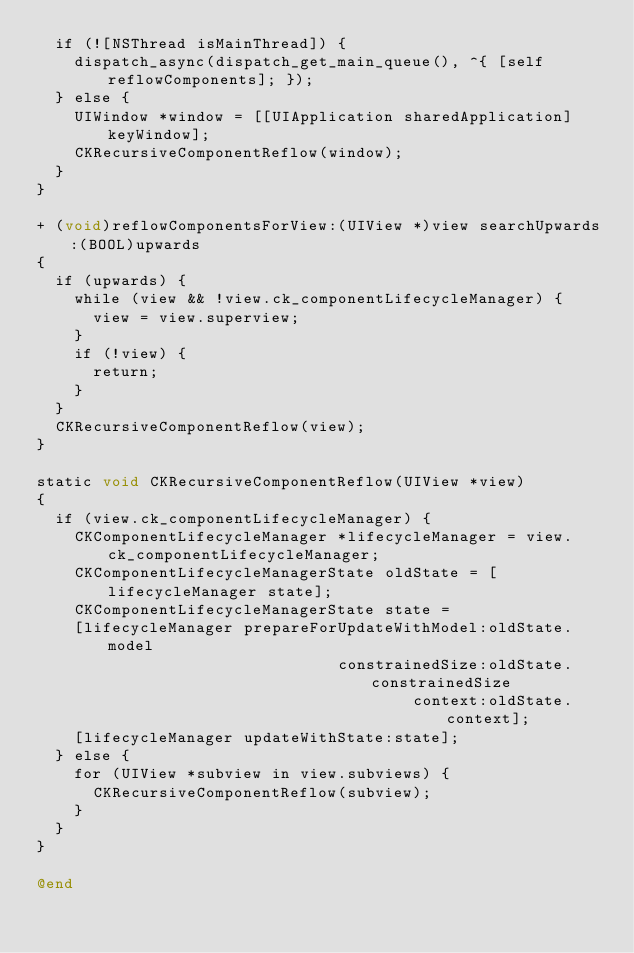Convert code to text. <code><loc_0><loc_0><loc_500><loc_500><_ObjectiveC_>  if (![NSThread isMainThread]) {
    dispatch_async(dispatch_get_main_queue(), ^{ [self reflowComponents]; });
  } else {
    UIWindow *window = [[UIApplication sharedApplication] keyWindow];
    CKRecursiveComponentReflow(window);
  }
}

+ (void)reflowComponentsForView:(UIView *)view searchUpwards:(BOOL)upwards
{
  if (upwards) {
    while (view && !view.ck_componentLifecycleManager) {
      view = view.superview;
    }
    if (!view) {
      return;
    }
  }
  CKRecursiveComponentReflow(view);
}

static void CKRecursiveComponentReflow(UIView *view)
{
  if (view.ck_componentLifecycleManager) {
    CKComponentLifecycleManager *lifecycleManager = view.ck_componentLifecycleManager;
    CKComponentLifecycleManagerState oldState = [lifecycleManager state];
    CKComponentLifecycleManagerState state =
    [lifecycleManager prepareForUpdateWithModel:oldState.model
                                constrainedSize:oldState.constrainedSize
                                        context:oldState.context];
    [lifecycleManager updateWithState:state];
  } else {
    for (UIView *subview in view.subviews) {
      CKRecursiveComponentReflow(subview);
    }
  }
}

@end
</code> 